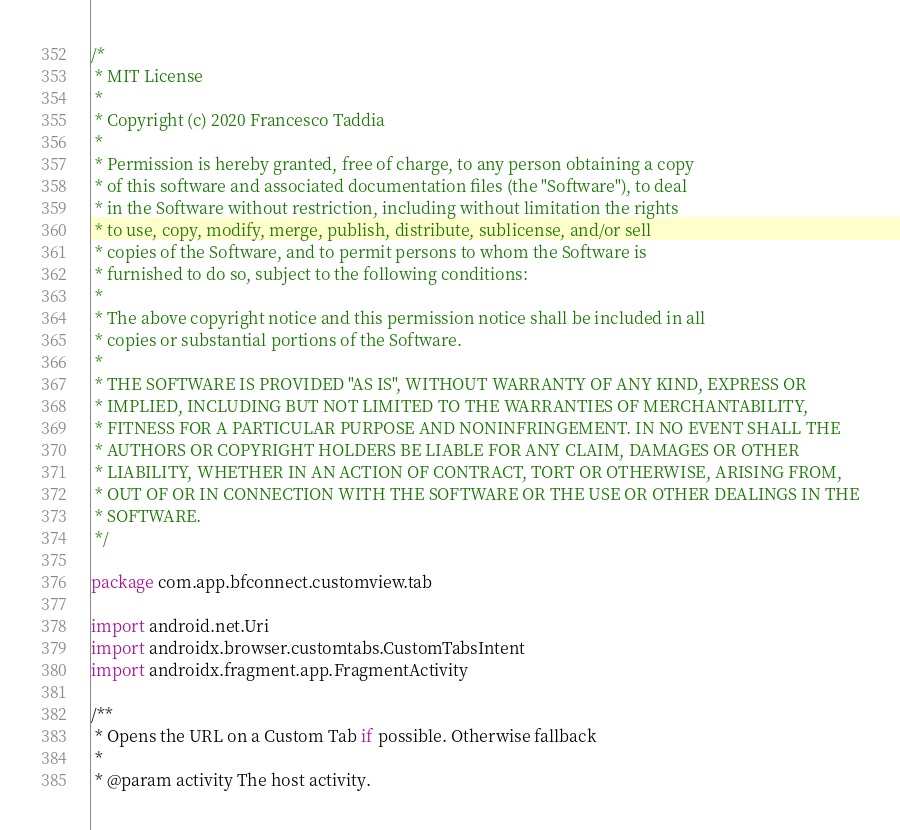Convert code to text. <code><loc_0><loc_0><loc_500><loc_500><_Kotlin_>/*
 * MIT License
 *
 * Copyright (c) 2020 Francesco Taddia
 *
 * Permission is hereby granted, free of charge, to any person obtaining a copy
 * of this software and associated documentation files (the "Software"), to deal
 * in the Software without restriction, including without limitation the rights
 * to use, copy, modify, merge, publish, distribute, sublicense, and/or sell
 * copies of the Software, and to permit persons to whom the Software is
 * furnished to do so, subject to the following conditions:
 *
 * The above copyright notice and this permission notice shall be included in all
 * copies or substantial portions of the Software.
 *
 * THE SOFTWARE IS PROVIDED "AS IS", WITHOUT WARRANTY OF ANY KIND, EXPRESS OR
 * IMPLIED, INCLUDING BUT NOT LIMITED TO THE WARRANTIES OF MERCHANTABILITY,
 * FITNESS FOR A PARTICULAR PURPOSE AND NONINFRINGEMENT. IN NO EVENT SHALL THE
 * AUTHORS OR COPYRIGHT HOLDERS BE LIABLE FOR ANY CLAIM, DAMAGES OR OTHER
 * LIABILITY, WHETHER IN AN ACTION OF CONTRACT, TORT OR OTHERWISE, ARISING FROM,
 * OUT OF OR IN CONNECTION WITH THE SOFTWARE OR THE USE OR OTHER DEALINGS IN THE
 * SOFTWARE.
 */

package com.app.bfconnect.customview.tab

import android.net.Uri
import androidx.browser.customtabs.CustomTabsIntent
import androidx.fragment.app.FragmentActivity

/**
 * Opens the URL on a Custom Tab if possible. Otherwise fallback
 *
 * @param activity The host activity.</code> 